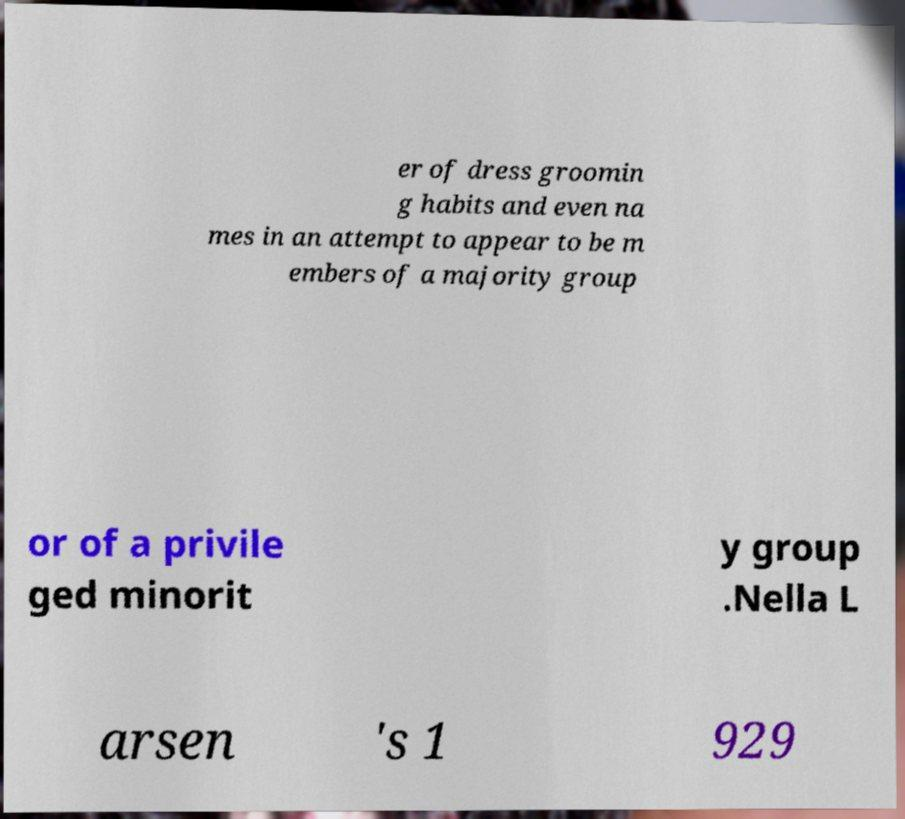Could you extract and type out the text from this image? er of dress groomin g habits and even na mes in an attempt to appear to be m embers of a majority group or of a privile ged minorit y group .Nella L arsen 's 1 929 